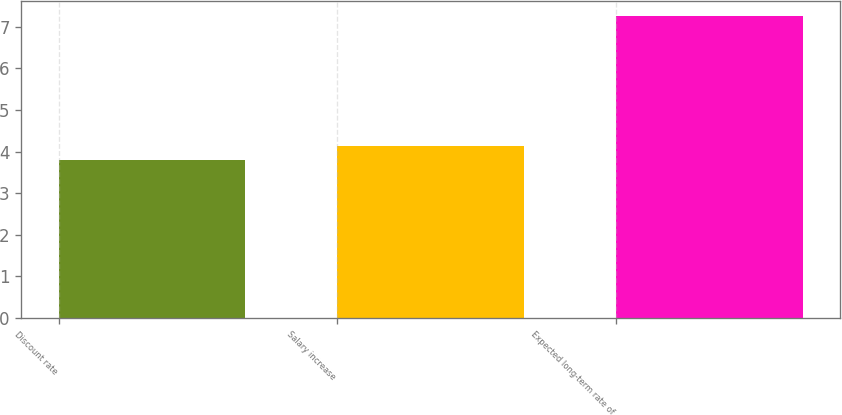Convert chart. <chart><loc_0><loc_0><loc_500><loc_500><bar_chart><fcel>Discount rate<fcel>Salary increase<fcel>Expected long-term rate of<nl><fcel>3.8<fcel>4.14<fcel>7.25<nl></chart> 